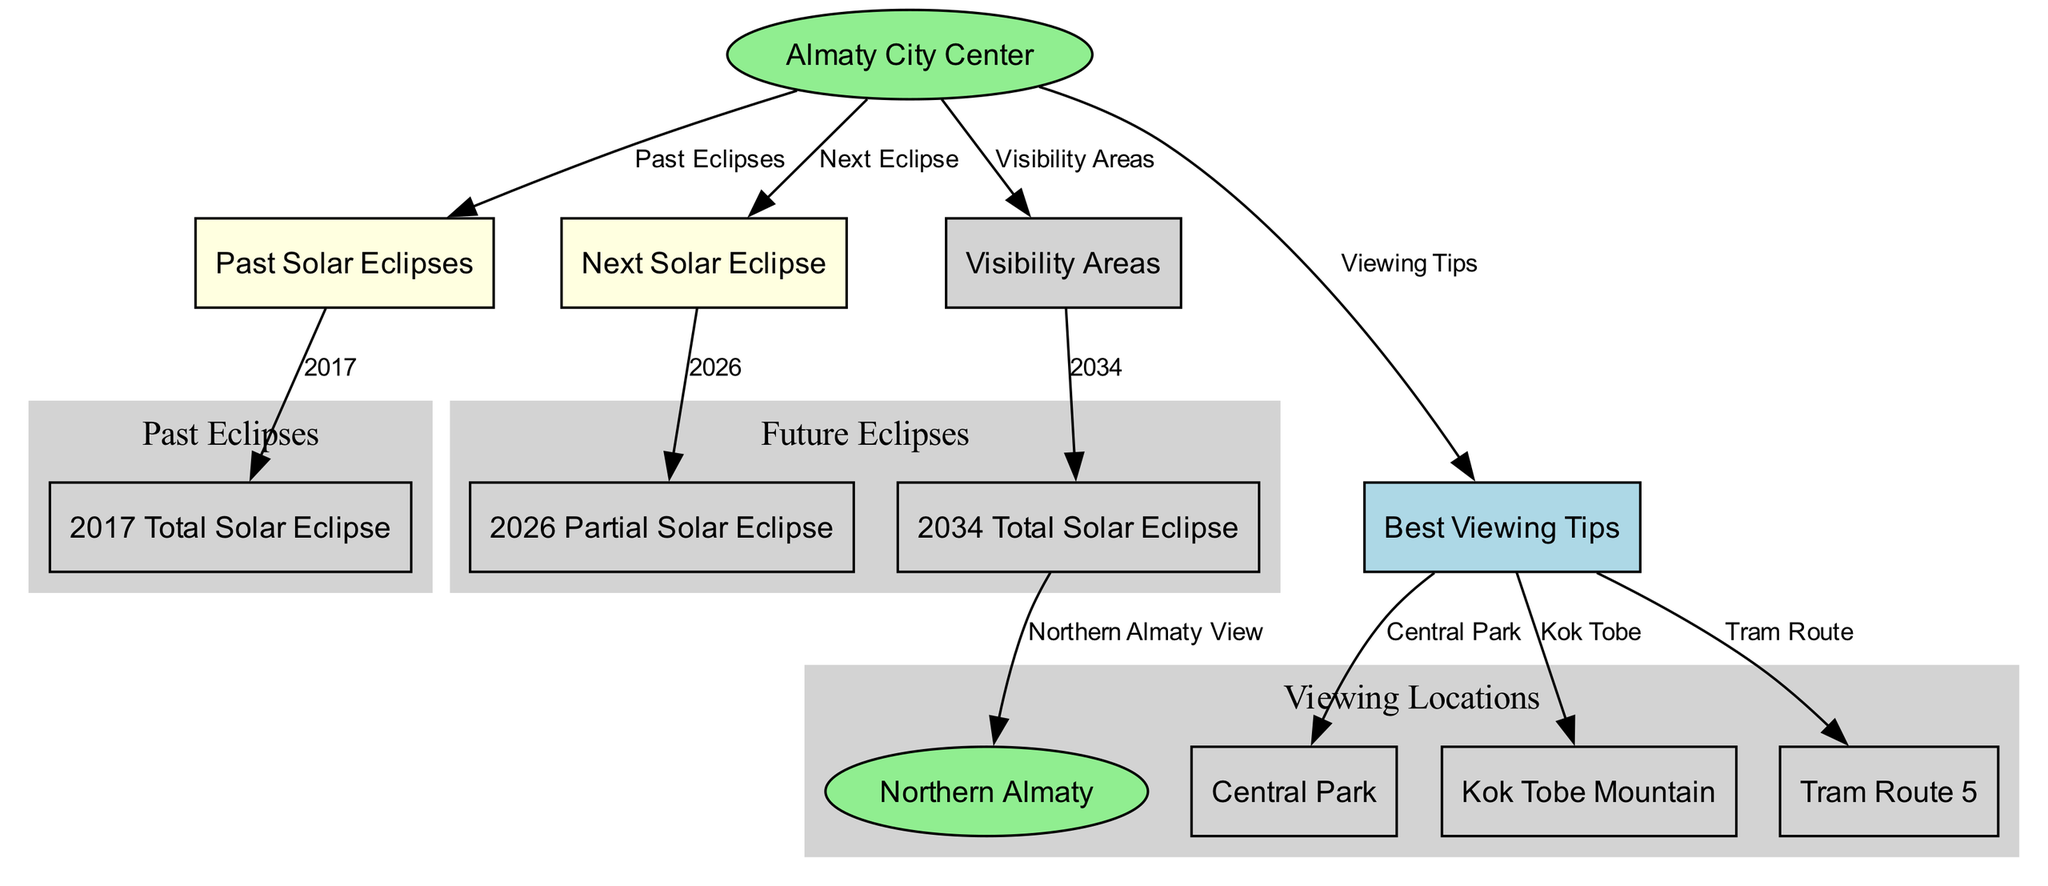What is the next solar eclipse observable in Almaty? The diagram indicates that the next solar eclipse is the partial solar eclipse in 2026, which is linked from the "Next Eclipse" node to the "Partial Solar Eclipse 2026" node.
Answer: Partial Solar Eclipse 2026 How many past solar eclipses are shown in the diagram? The diagram has one past solar eclipse node which represents the 2017 Total Solar Eclipse, linked from the "Past Solar Eclipses" node. The count of distinct nodes for past eclipses is one.
Answer: One Which area offers the best viewing for the total solar eclipse in 2034? The visibility area nodes lead to the "Total Solar Eclipse 2034" node, from which "Northern Almaty View" is specifically mentioned as the best viewing area.
Answer: Northern Almaty View What is the label of the node connected to "Almaty City Center" that indicates viewing tips? The diagram shows an edge leading from the "Almaty City Center" node to the "Best Viewing Tips" node, indicating that tips for viewing solar eclipses are provided in that node.
Answer: Best Viewing Tips Where can I view the next solar eclipse during a tram ride? From the "Best Viewing Tips" node, there is a direct connection to "Tram Route," suggesting that viewing the eclipse from a tram is possible, as per the tips given.
Answer: Tram Route What type of solar eclipse occurred in 2017? The "Total Solar Eclipse" is labeled in the node for the year 2017, which is linked from the past eclipses node, providing the eclipse type directly.
Answer: Total Solar Eclipse How many nodes are there in the visibility areas section? The visibility areas section contains three nodes: "Total Solar Eclipse 2034," "Northern Almaty View," "Central Park," and "Kok Tobe," so the total is counted to four nodes including the main area node.
Answer: Four What are two recommended locations for eclipse viewing? The "Best Viewing Tips" node points to both "Central Park" and "Kok Tobe," which are suggested locations for viewing eclipses.
Answer: Central Park and Kok Tobe Which route is highlighted for tram commuters wanting to view a solar eclipse? The diagram connects "Best Viewing Tips" to "Tram Route 5," indicating that this tram route is highlighted for viewing purposes during a solar eclipse.
Answer: Tram Route 5 